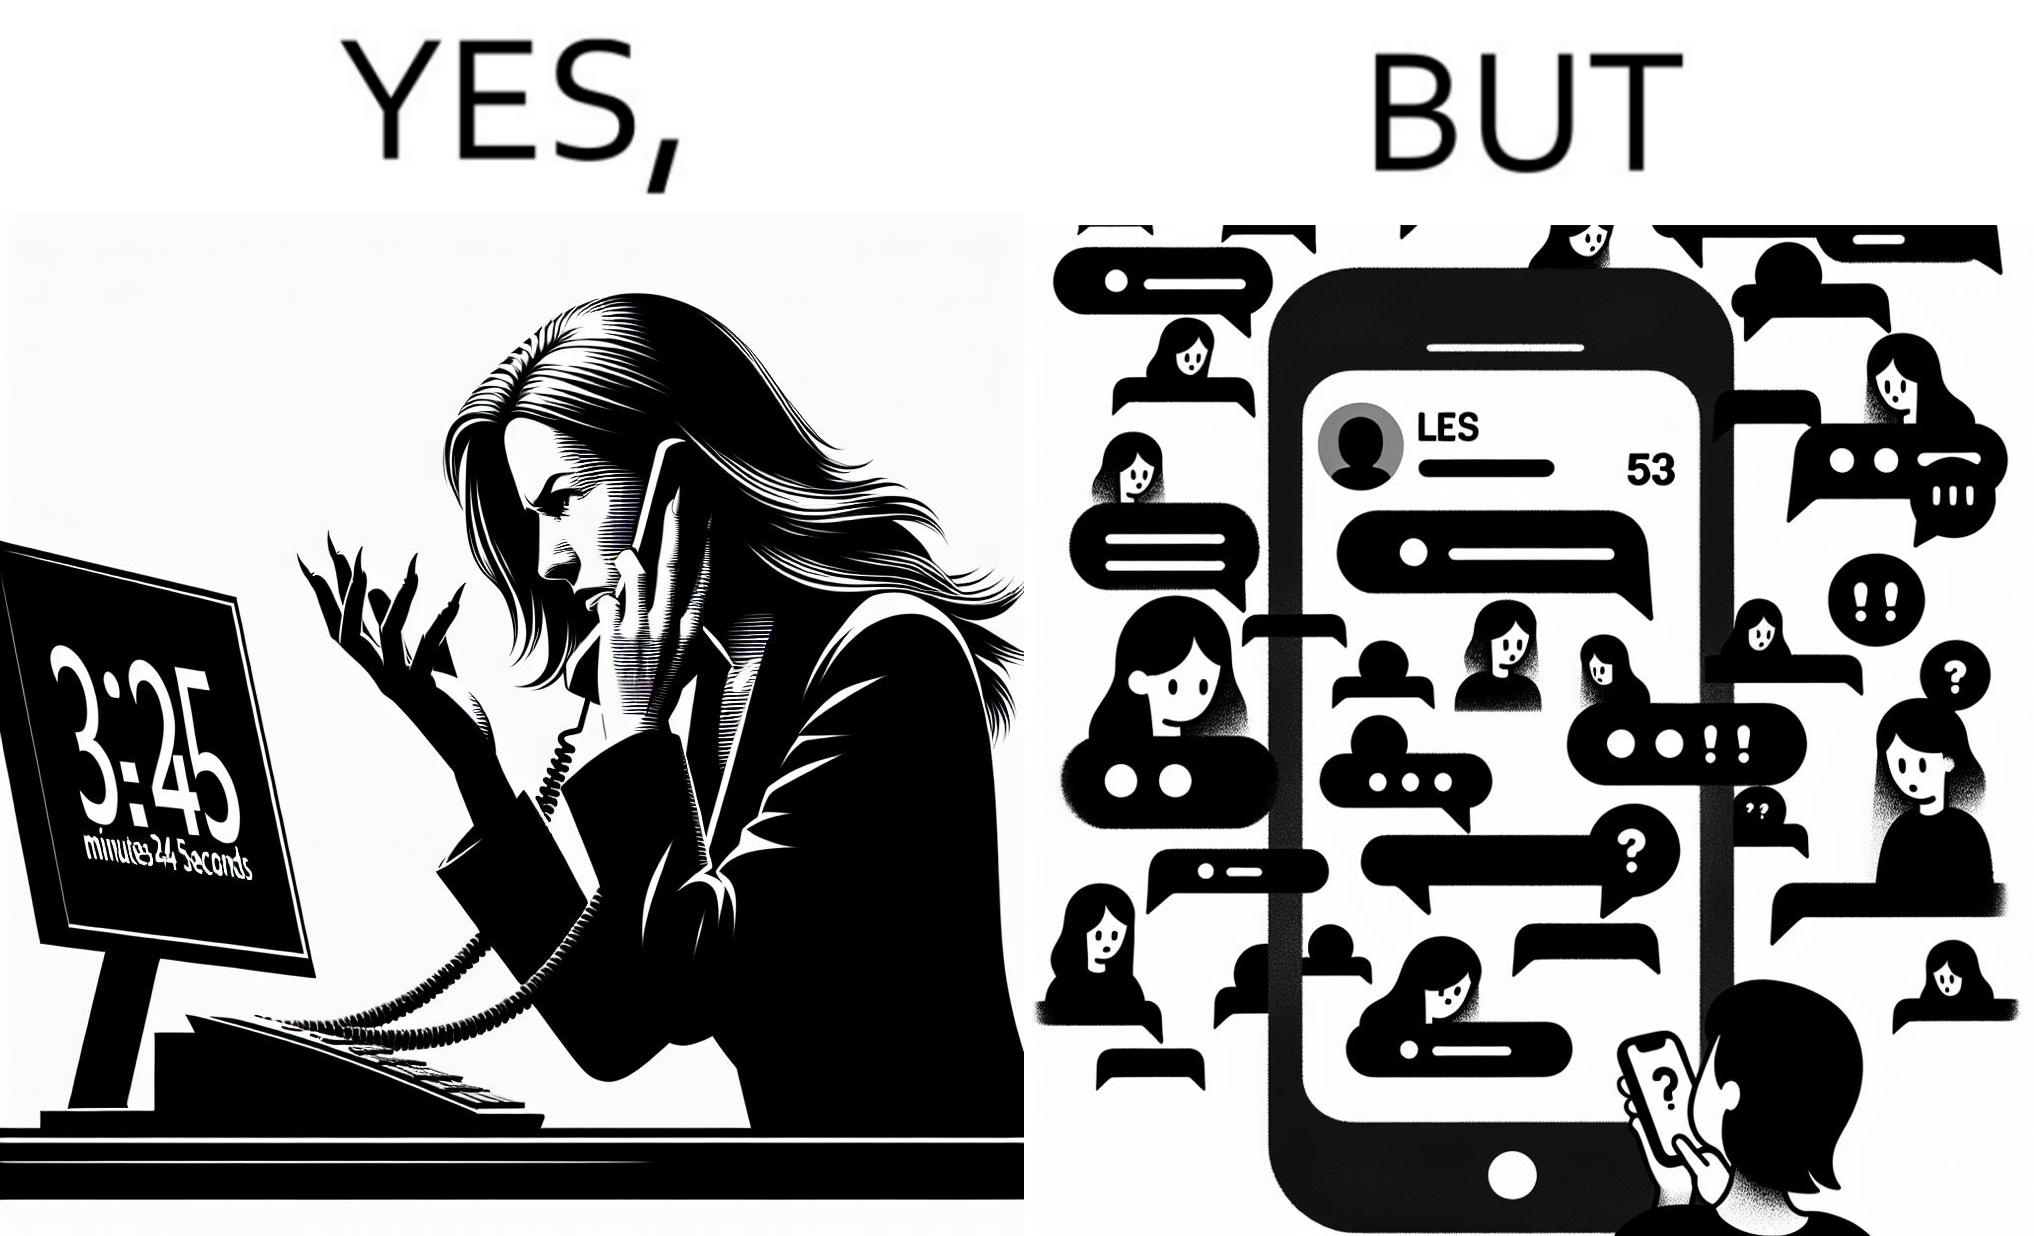Describe what you see in the left and right parts of this image. In the left part of the image: The image shows an annoyed woman talking to the representative in the call center on her mobile phone for over 23 minutes and 45 seconds. In the right part of the image: The image shows the chats of a person on their phone. There are a total of 53 unread chats. In the unanswered chats, the people on the other end are asking if this person got their message or if this person is ignoring them. 